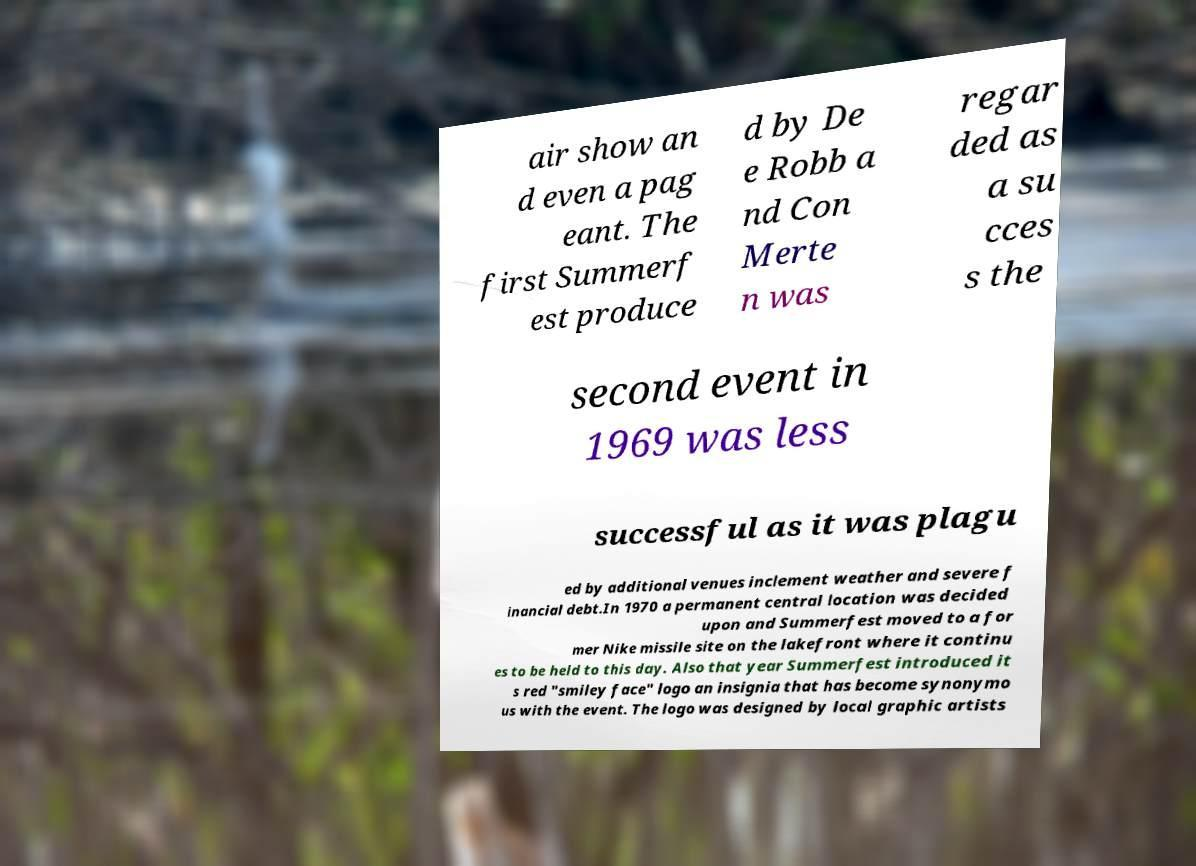I need the written content from this picture converted into text. Can you do that? air show an d even a pag eant. The first Summerf est produce d by De e Robb a nd Con Merte n was regar ded as a su cces s the second event in 1969 was less successful as it was plagu ed by additional venues inclement weather and severe f inancial debt.In 1970 a permanent central location was decided upon and Summerfest moved to a for mer Nike missile site on the lakefront where it continu es to be held to this day. Also that year Summerfest introduced it s red "smiley face" logo an insignia that has become synonymo us with the event. The logo was designed by local graphic artists 